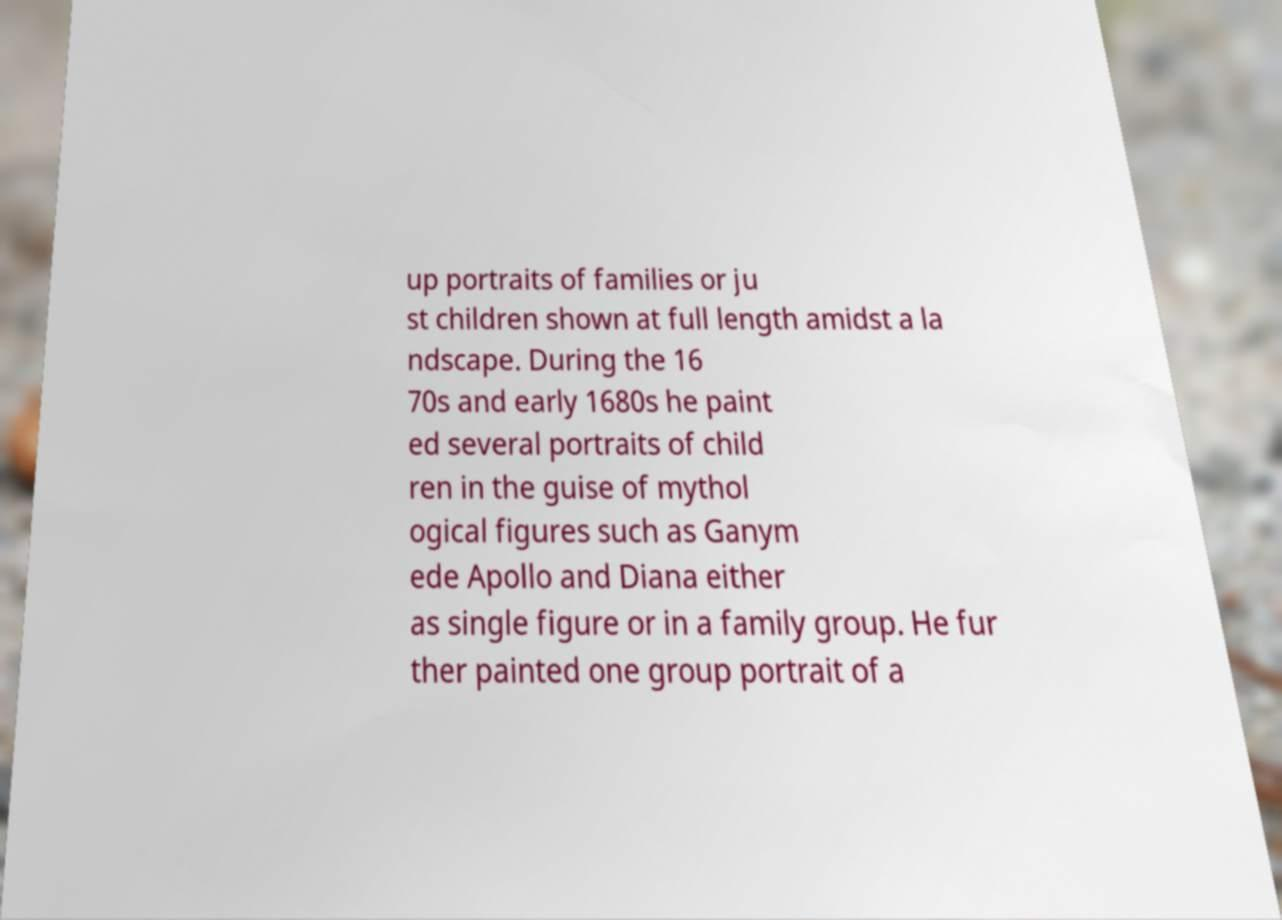Can you accurately transcribe the text from the provided image for me? up portraits of families or ju st children shown at full length amidst a la ndscape. During the 16 70s and early 1680s he paint ed several portraits of child ren in the guise of mythol ogical figures such as Ganym ede Apollo and Diana either as single figure or in a family group. He fur ther painted one group portrait of a 